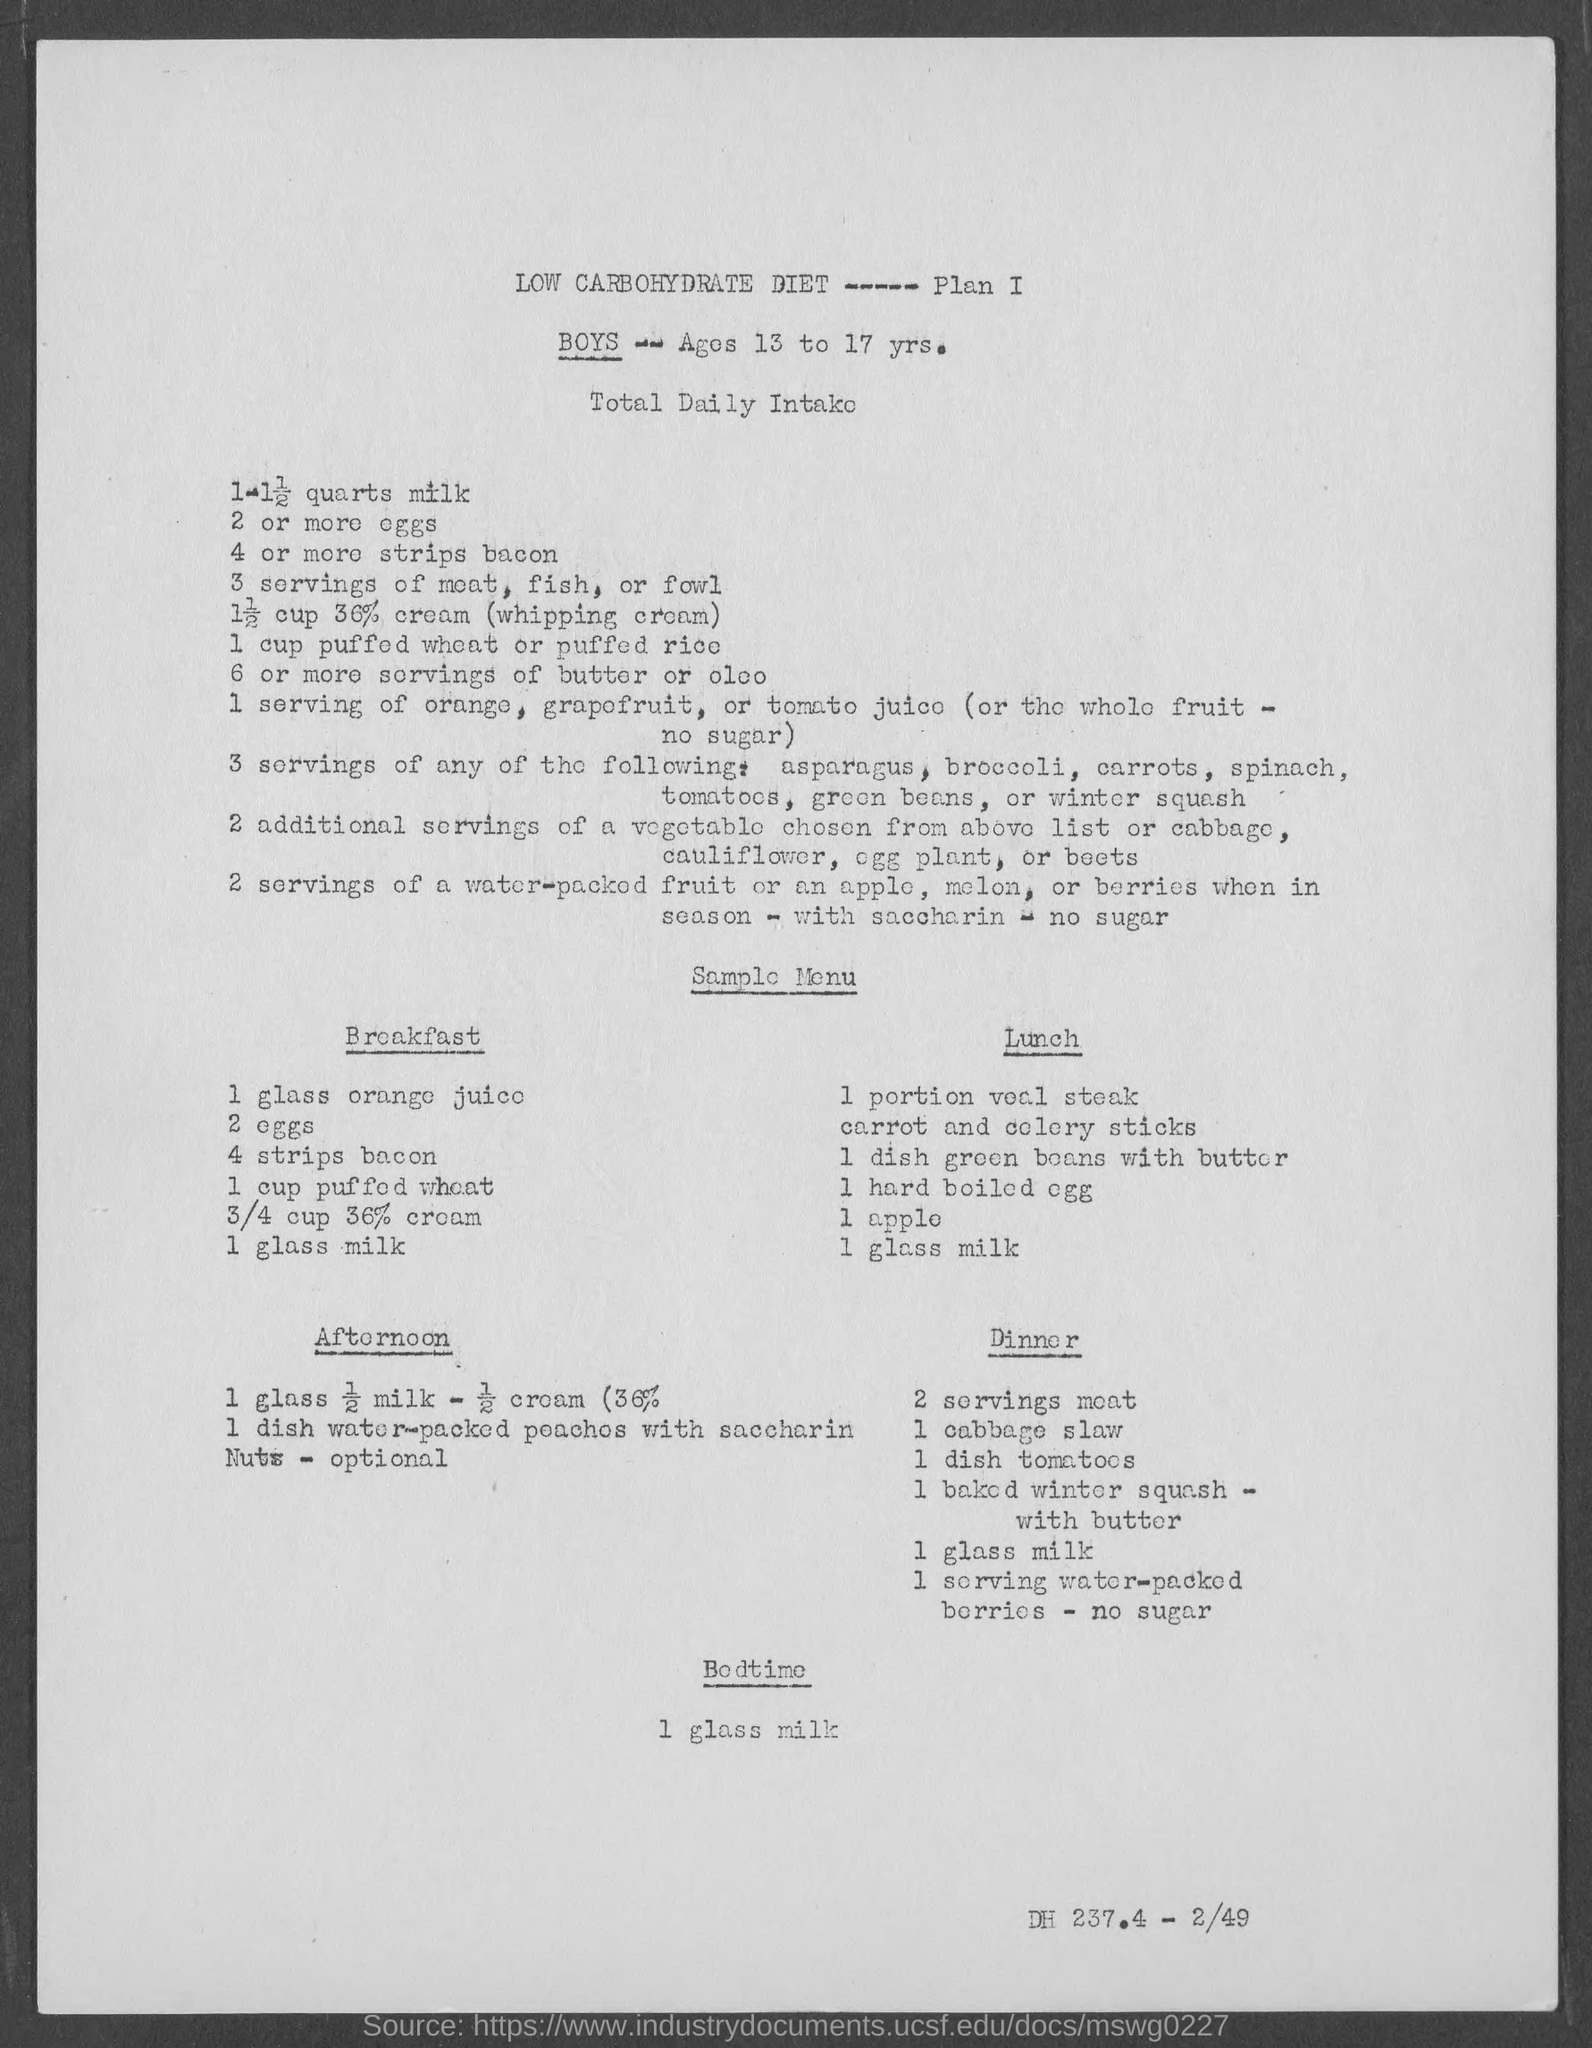What is the age of the boys ?
Your response must be concise. 13 to 17 yrs. What is the percentage of whipping cream added?
Offer a terse response. 36%. What is the first item for breakfast according to the diet plan?
Your response must be concise. 1 glass orange juice. What is the first item for Lunch according to the diet plan?
Provide a succinct answer. 1 portion veal steak. What is the first item for Dinner according to the diet plan?
Your answer should be very brief. 2 servings meat. What is the food on Bedtime?
Ensure brevity in your answer.  1 glass milk. What is the second item for breakfast according to the diet plan?
Ensure brevity in your answer.  2 eggs. What is the third item for breakfast according to the diet plan?
Give a very brief answer. 4 strips bacon. What is the fourth item for breakfast according to the diet plan?
Provide a succinct answer. 1 cup puffed wheat. What is the sixth item for breakfast according to the diet plan?
Give a very brief answer. 1 glass milk. 